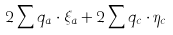Convert formula to latex. <formula><loc_0><loc_0><loc_500><loc_500>2 \sum q _ { a } \cdot \xi _ { a } + 2 \sum q _ { c } \cdot \eta _ { c }</formula> 